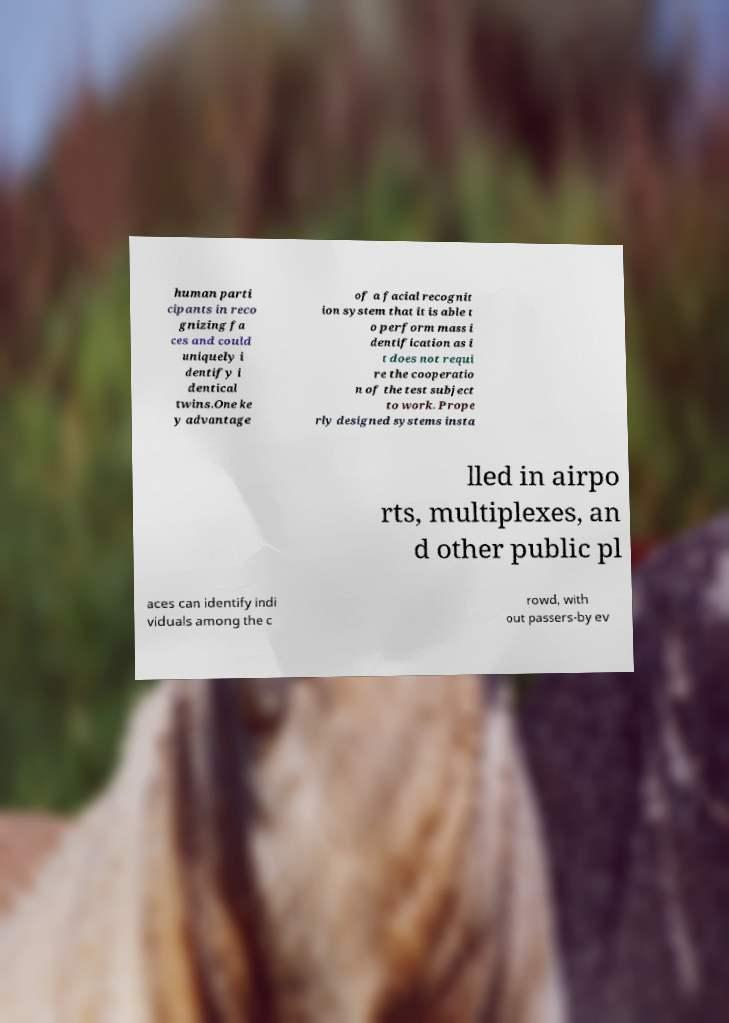For documentation purposes, I need the text within this image transcribed. Could you provide that? human parti cipants in reco gnizing fa ces and could uniquely i dentify i dentical twins.One ke y advantage of a facial recognit ion system that it is able t o perform mass i dentification as i t does not requi re the cooperatio n of the test subject to work. Prope rly designed systems insta lled in airpo rts, multiplexes, an d other public pl aces can identify indi viduals among the c rowd, with out passers-by ev 